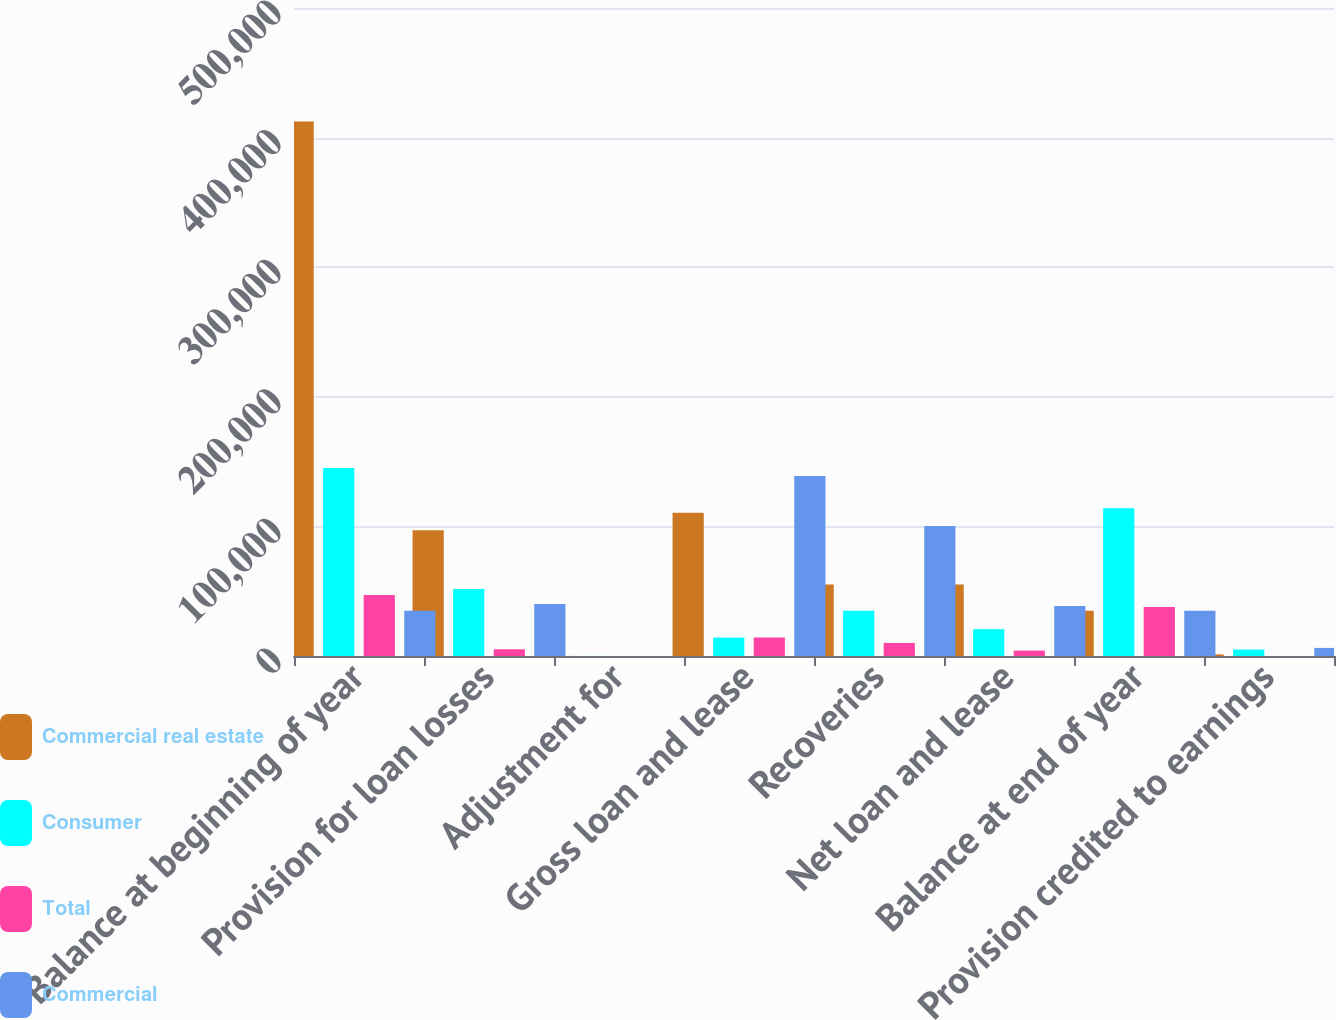<chart> <loc_0><loc_0><loc_500><loc_500><stacked_bar_chart><ecel><fcel>Balance at beginning of year<fcel>Provision for loan losses<fcel>Adjustment for<fcel>Gross loan and lease<fcel>Recoveries<fcel>Net loan and lease<fcel>Balance at end of year<fcel>Provision credited to earnings<nl><fcel>Commercial real estate<fcel>412514<fcel>96995<fcel>57<fcel>110437<fcel>55262<fcel>55175<fcel>34897<fcel>1235<nl><fcel>Consumer<fcel>145009<fcel>51777<fcel>57<fcel>14194<fcel>34897<fcel>20703<fcel>113992<fcel>4991<nl><fcel>Total<fcel>47140<fcel>5183<fcel>5<fcel>14298<fcel>10115<fcel>4183<fcel>37779<fcel>12<nl><fcel>Commercial<fcel>34897<fcel>40035<fcel>5<fcel>138929<fcel>100274<fcel>38655<fcel>34897<fcel>6238<nl></chart> 